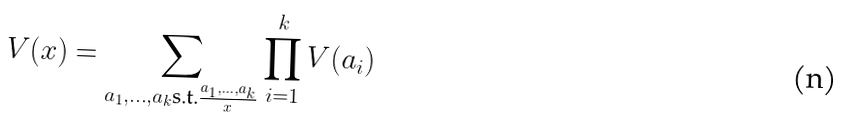<formula> <loc_0><loc_0><loc_500><loc_500>V ( x ) = \sum _ { a _ { 1 } , \dots , a _ { k } \text {s.t.} \frac { a _ { 1 } , \dots , a _ { k } } { x } } \prod _ { i = 1 } ^ { k } V ( a _ { i } )</formula> 